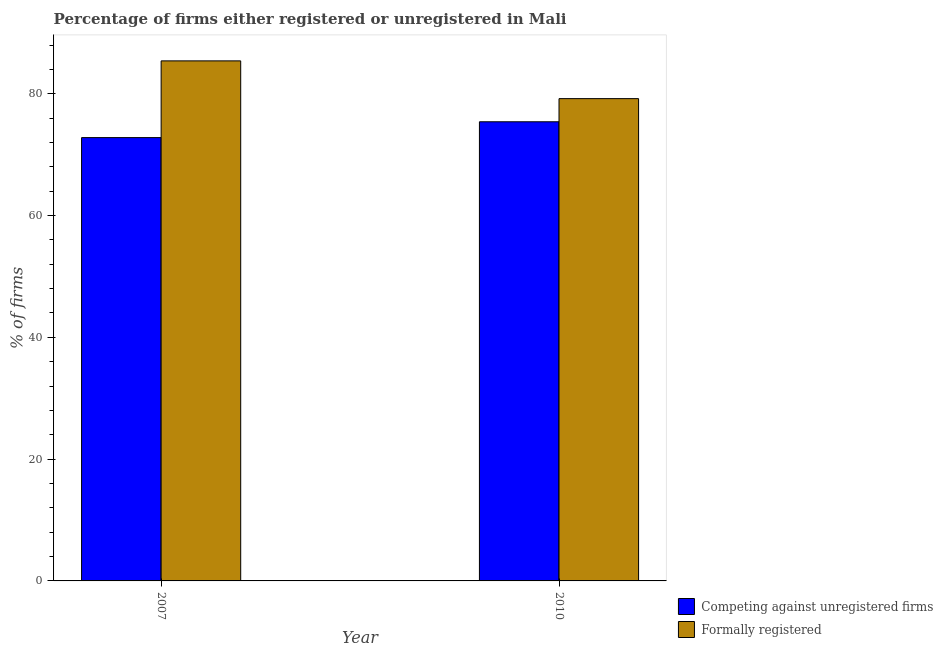How many groups of bars are there?
Provide a succinct answer. 2. Are the number of bars per tick equal to the number of legend labels?
Make the answer very short. Yes. Are the number of bars on each tick of the X-axis equal?
Give a very brief answer. Yes. How many bars are there on the 1st tick from the right?
Your response must be concise. 2. What is the percentage of registered firms in 2010?
Keep it short and to the point. 75.4. Across all years, what is the maximum percentage of formally registered firms?
Make the answer very short. 85.4. Across all years, what is the minimum percentage of registered firms?
Provide a succinct answer. 72.8. What is the total percentage of formally registered firms in the graph?
Provide a short and direct response. 164.6. What is the difference between the percentage of formally registered firms in 2007 and that in 2010?
Your answer should be compact. 6.2. What is the difference between the percentage of registered firms in 2010 and the percentage of formally registered firms in 2007?
Ensure brevity in your answer.  2.6. What is the average percentage of formally registered firms per year?
Ensure brevity in your answer.  82.3. In the year 2007, what is the difference between the percentage of formally registered firms and percentage of registered firms?
Give a very brief answer. 0. What is the ratio of the percentage of formally registered firms in 2007 to that in 2010?
Provide a short and direct response. 1.08. Is the percentage of formally registered firms in 2007 less than that in 2010?
Keep it short and to the point. No. What does the 1st bar from the left in 2007 represents?
Your answer should be compact. Competing against unregistered firms. What does the 1st bar from the right in 2010 represents?
Provide a short and direct response. Formally registered. How many bars are there?
Ensure brevity in your answer.  4. Are all the bars in the graph horizontal?
Ensure brevity in your answer.  No. How many years are there in the graph?
Your response must be concise. 2. Does the graph contain any zero values?
Your response must be concise. No. How are the legend labels stacked?
Ensure brevity in your answer.  Vertical. What is the title of the graph?
Ensure brevity in your answer.  Percentage of firms either registered or unregistered in Mali. What is the label or title of the X-axis?
Provide a short and direct response. Year. What is the label or title of the Y-axis?
Offer a terse response. % of firms. What is the % of firms in Competing against unregistered firms in 2007?
Give a very brief answer. 72.8. What is the % of firms of Formally registered in 2007?
Provide a short and direct response. 85.4. What is the % of firms in Competing against unregistered firms in 2010?
Your response must be concise. 75.4. What is the % of firms in Formally registered in 2010?
Give a very brief answer. 79.2. Across all years, what is the maximum % of firms in Competing against unregistered firms?
Offer a terse response. 75.4. Across all years, what is the maximum % of firms of Formally registered?
Provide a short and direct response. 85.4. Across all years, what is the minimum % of firms of Competing against unregistered firms?
Make the answer very short. 72.8. Across all years, what is the minimum % of firms of Formally registered?
Make the answer very short. 79.2. What is the total % of firms of Competing against unregistered firms in the graph?
Your answer should be compact. 148.2. What is the total % of firms in Formally registered in the graph?
Make the answer very short. 164.6. What is the average % of firms of Competing against unregistered firms per year?
Offer a terse response. 74.1. What is the average % of firms of Formally registered per year?
Give a very brief answer. 82.3. In the year 2010, what is the difference between the % of firms of Competing against unregistered firms and % of firms of Formally registered?
Keep it short and to the point. -3.8. What is the ratio of the % of firms of Competing against unregistered firms in 2007 to that in 2010?
Offer a very short reply. 0.97. What is the ratio of the % of firms in Formally registered in 2007 to that in 2010?
Offer a very short reply. 1.08. What is the difference between the highest and the second highest % of firms in Competing against unregistered firms?
Your response must be concise. 2.6. What is the difference between the highest and the lowest % of firms of Competing against unregistered firms?
Provide a short and direct response. 2.6. What is the difference between the highest and the lowest % of firms in Formally registered?
Give a very brief answer. 6.2. 